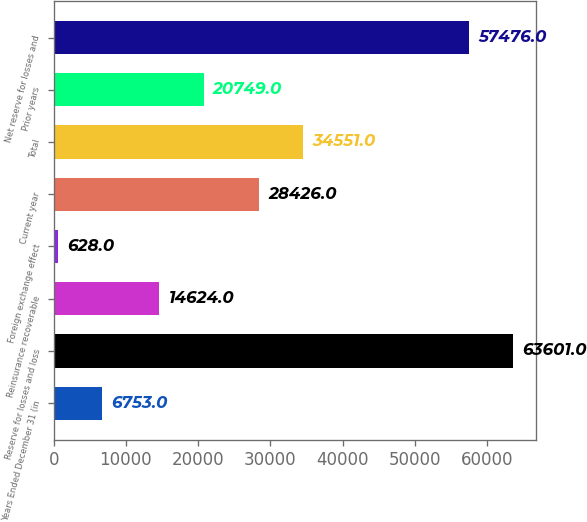<chart> <loc_0><loc_0><loc_500><loc_500><bar_chart><fcel>Years Ended December 31 (in<fcel>Reserve for losses and loss<fcel>Reinsurance recoverable<fcel>Foreign exchange effect<fcel>Current year<fcel>Total<fcel>Prior years<fcel>Net reserve for losses and<nl><fcel>6753<fcel>63601<fcel>14624<fcel>628<fcel>28426<fcel>34551<fcel>20749<fcel>57476<nl></chart> 